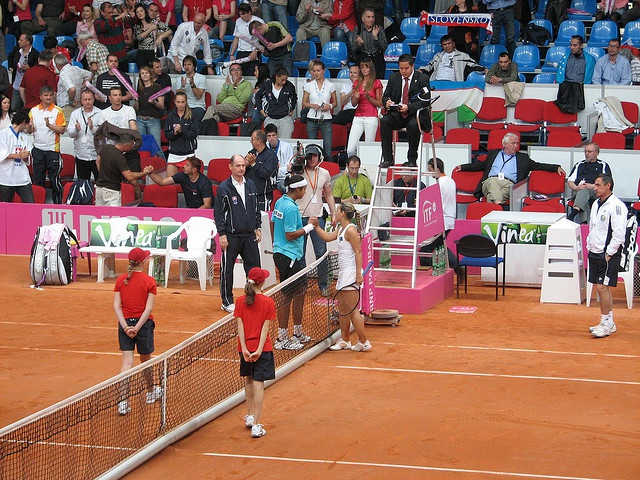Describe the objects in this image and their specific colors. I can see people in black, gray, lightgray, and darkgray tones, people in black, maroon, teal, and lightblue tones, people in black, gray, and lightgray tones, people in black, lavender, brown, and darkgray tones, and people in black and brown tones in this image. 